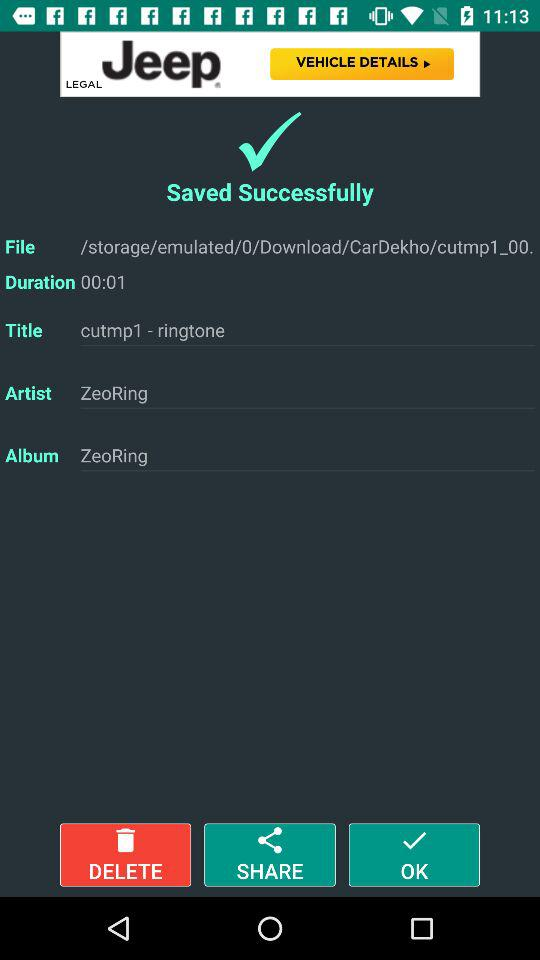Can you explain what's happening in this screenshot? This screenshot shows the interface of a smartphone music or media application. A music file has been successfully saved, as indicated by the checkmark and 'Saved Successfully' message. Details such as the file path, duration, title, artist, and album are presented, suggesting that the user may have edited a music file, possibly creating a custom ringtone using the application. 